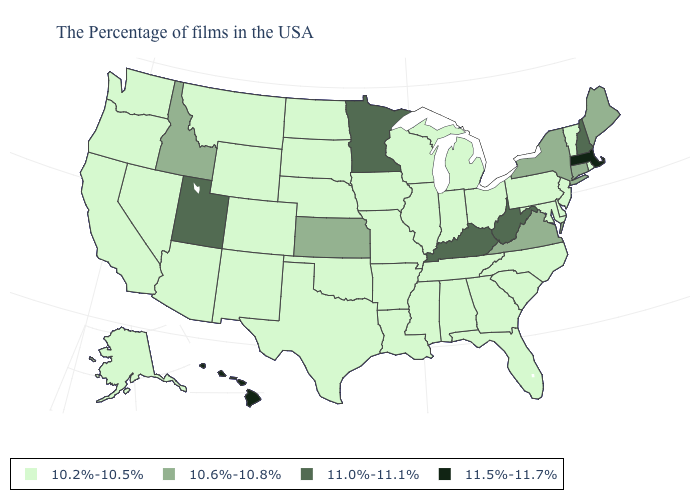Name the states that have a value in the range 10.2%-10.5%?
Short answer required. Rhode Island, Vermont, New Jersey, Delaware, Maryland, Pennsylvania, North Carolina, South Carolina, Ohio, Florida, Georgia, Michigan, Indiana, Alabama, Tennessee, Wisconsin, Illinois, Mississippi, Louisiana, Missouri, Arkansas, Iowa, Nebraska, Oklahoma, Texas, South Dakota, North Dakota, Wyoming, Colorado, New Mexico, Montana, Arizona, Nevada, California, Washington, Oregon, Alaska. What is the value of Utah?
Keep it brief. 11.0%-11.1%. Name the states that have a value in the range 10.6%-10.8%?
Concise answer only. Maine, Connecticut, New York, Virginia, Kansas, Idaho. Does the first symbol in the legend represent the smallest category?
Answer briefly. Yes. What is the value of New York?
Give a very brief answer. 10.6%-10.8%. Name the states that have a value in the range 11.5%-11.7%?
Quick response, please. Massachusetts, Hawaii. Name the states that have a value in the range 11.0%-11.1%?
Give a very brief answer. New Hampshire, West Virginia, Kentucky, Minnesota, Utah. Does Iowa have a higher value than New York?
Be succinct. No. What is the value of Minnesota?
Answer briefly. 11.0%-11.1%. Name the states that have a value in the range 11.0%-11.1%?
Keep it brief. New Hampshire, West Virginia, Kentucky, Minnesota, Utah. Name the states that have a value in the range 11.5%-11.7%?
Give a very brief answer. Massachusetts, Hawaii. Name the states that have a value in the range 10.2%-10.5%?
Give a very brief answer. Rhode Island, Vermont, New Jersey, Delaware, Maryland, Pennsylvania, North Carolina, South Carolina, Ohio, Florida, Georgia, Michigan, Indiana, Alabama, Tennessee, Wisconsin, Illinois, Mississippi, Louisiana, Missouri, Arkansas, Iowa, Nebraska, Oklahoma, Texas, South Dakota, North Dakota, Wyoming, Colorado, New Mexico, Montana, Arizona, Nevada, California, Washington, Oregon, Alaska. Name the states that have a value in the range 11.0%-11.1%?
Write a very short answer. New Hampshire, West Virginia, Kentucky, Minnesota, Utah. How many symbols are there in the legend?
Short answer required. 4. Name the states that have a value in the range 10.2%-10.5%?
Keep it brief. Rhode Island, Vermont, New Jersey, Delaware, Maryland, Pennsylvania, North Carolina, South Carolina, Ohio, Florida, Georgia, Michigan, Indiana, Alabama, Tennessee, Wisconsin, Illinois, Mississippi, Louisiana, Missouri, Arkansas, Iowa, Nebraska, Oklahoma, Texas, South Dakota, North Dakota, Wyoming, Colorado, New Mexico, Montana, Arizona, Nevada, California, Washington, Oregon, Alaska. 